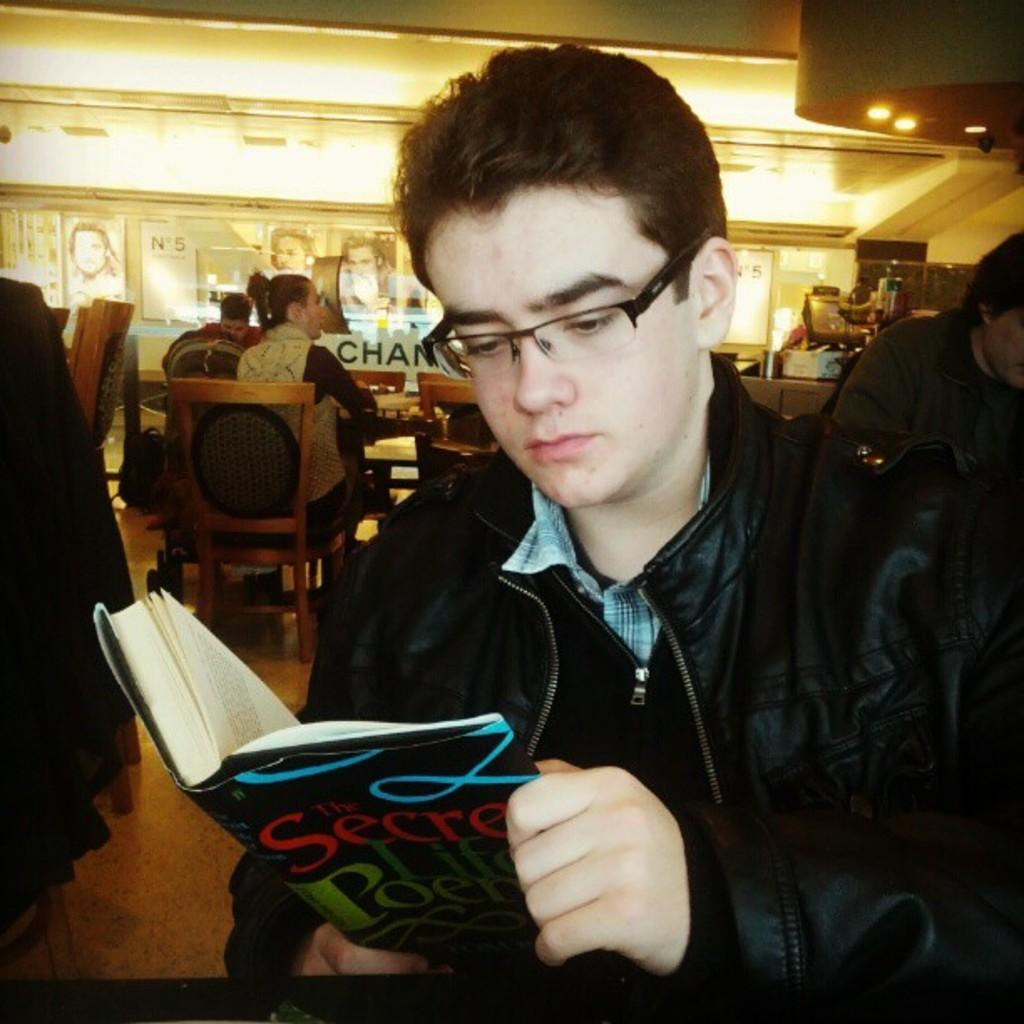What is the person in the image wearing? The person is wearing a black jacket in the image. What is the person doing while wearing the black jacket? The person is sitting and reading a book. Where is the book located in relation to the person? The book is in front of the person. Are there any other people in the image? Yes, there are other persons sitting in the image. How are the other persons positioned in relation to the person reading the book? The other persons are sitting behind the person reading the book. What type of brass can be seen on the cat in the image? There is no cat or brass present in the image. What is the person reading from the can in the image? There is no can present in the image, and the person is reading a book, not from a can. 